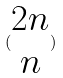Convert formula to latex. <formula><loc_0><loc_0><loc_500><loc_500>( \begin{matrix} 2 n \\ n \end{matrix} )</formula> 